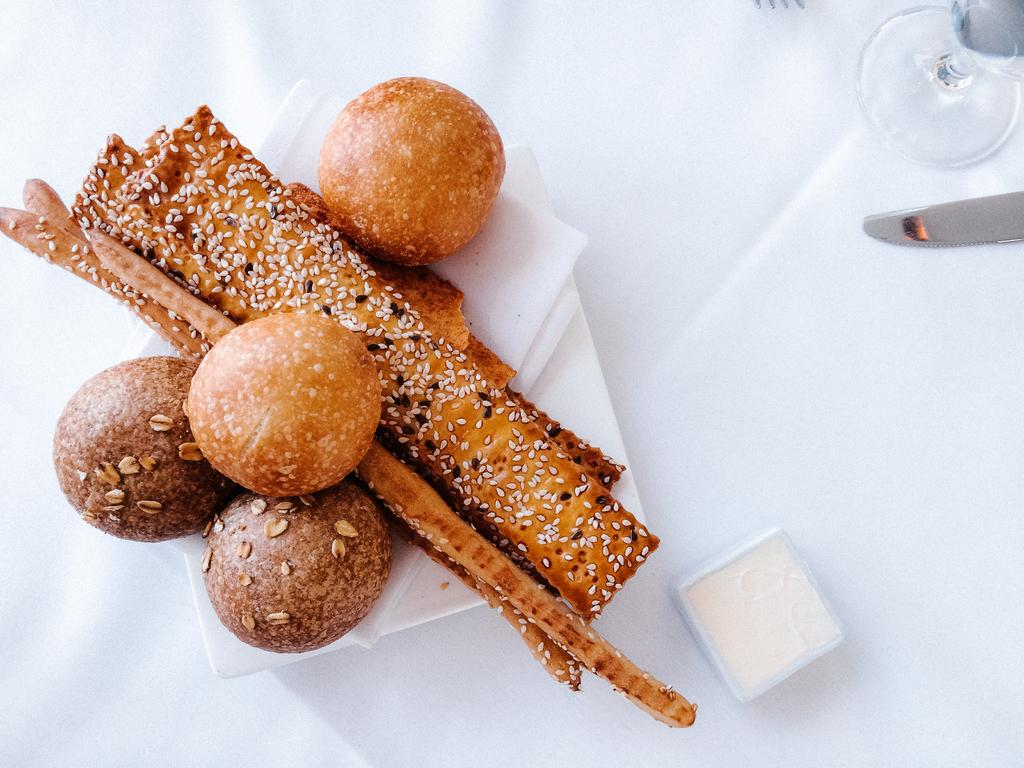What type of utensil is visible in the image? There is a knife in the image. What type of container is present in the image? There is a glass in the image. What is the unidentified object in the image? There is an object in the image, but its specific nature is not mentioned in the facts. What is on the plate in the image? There are food items on a plate in the image. What color is the surface in the image? The white surface is present in the image. What type of pie is being served in the hall in the image? There is no pie or hall mentioned in the image. The image only contains a knife, a glass, an unidentified object, food items on a plate, and a white surface. 